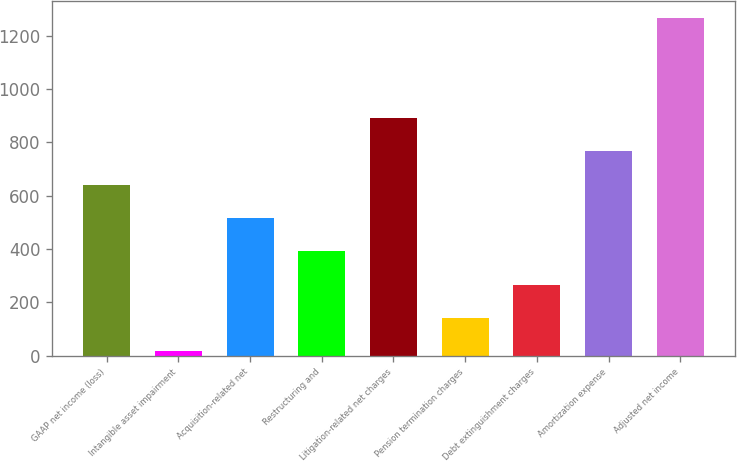<chart> <loc_0><loc_0><loc_500><loc_500><bar_chart><fcel>GAAP net income (loss)<fcel>Intangible asset impairment<fcel>Acquisition-related net<fcel>Restructuring and<fcel>Litigation-related net charges<fcel>Pension termination charges<fcel>Debt extinguishment charges<fcel>Amortization expense<fcel>Adjusted net income<nl><fcel>641.5<fcel>16<fcel>516.4<fcel>391.3<fcel>891.7<fcel>141.1<fcel>266.2<fcel>766.6<fcel>1267<nl></chart> 